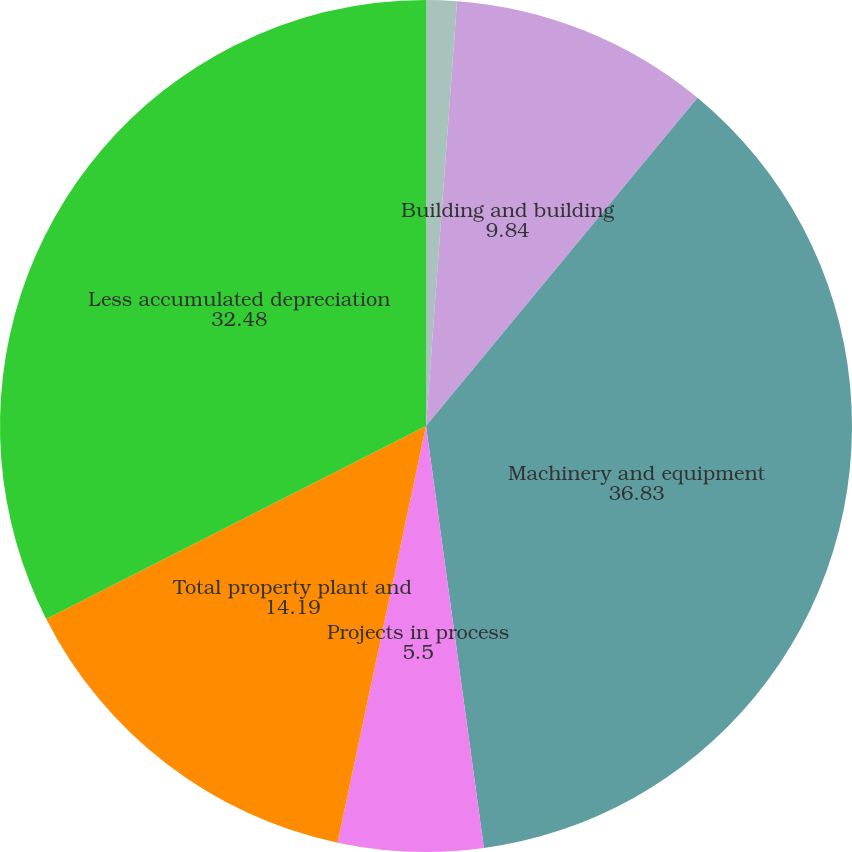Convert chart to OTSL. <chart><loc_0><loc_0><loc_500><loc_500><pie_chart><fcel>Land<fcel>Building and building<fcel>Machinery and equipment<fcel>Projects in process<fcel>Total property plant and<fcel>Less accumulated depreciation<nl><fcel>1.16%<fcel>9.84%<fcel>36.83%<fcel>5.5%<fcel>14.19%<fcel>32.48%<nl></chart> 